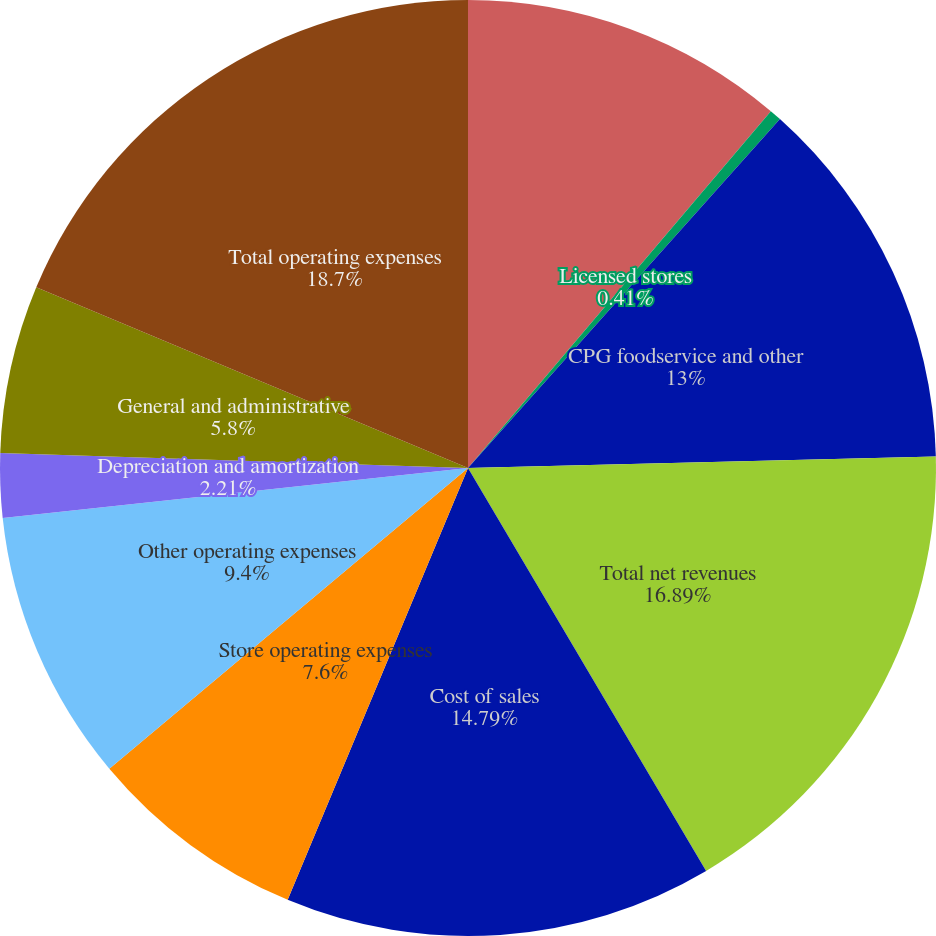Convert chart. <chart><loc_0><loc_0><loc_500><loc_500><pie_chart><fcel>Company-operated stores<fcel>Licensed stores<fcel>CPG foodservice and other<fcel>Total net revenues<fcel>Cost of sales<fcel>Store operating expenses<fcel>Other operating expenses<fcel>Depreciation and amortization<fcel>General and administrative<fcel>Total operating expenses<nl><fcel>11.2%<fcel>0.41%<fcel>13.0%<fcel>16.89%<fcel>14.79%<fcel>7.6%<fcel>9.4%<fcel>2.21%<fcel>5.8%<fcel>18.69%<nl></chart> 